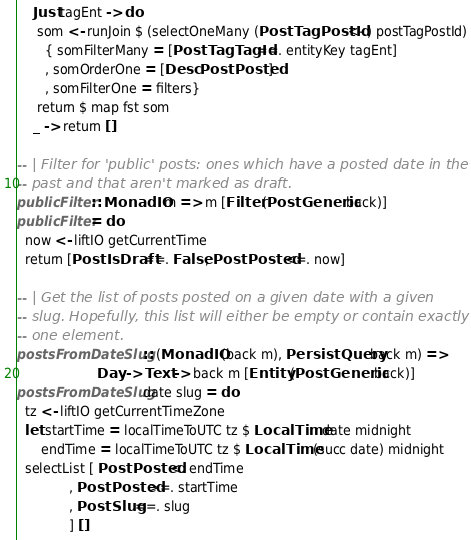<code> <loc_0><loc_0><loc_500><loc_500><_Haskell_>    Just tagEnt -> do
     som <- runJoin $ (selectOneMany (PostTagPostId <-.) postTagPostId)
       { somFilterMany = [PostTagTagId ==. entityKey tagEnt]
       , somOrderOne = [Desc PostPosted]
       , somFilterOne = filters}
     return $ map fst som
    _ -> return []

-- | Filter for 'public' posts: ones which have a posted date in the
-- past and that aren't marked as draft.
publicFilter :: MonadIO m => m [Filter (PostGeneric back)]
publicFilter = do
  now <- liftIO getCurrentTime
  return [PostIsDraft ==. False, PostPosted <=. now]

-- | Get the list of posts posted on a given date with a given
-- slug. Hopefully, this list will either be empty or contain exactly
-- one element.
postsFromDateSlug :: (MonadIO (back m), PersistQuery back m) =>
                    Day -> Text -> back m [Entity (PostGeneric back)]
postsFromDateSlug date slug = do
  tz <- liftIO getCurrentTimeZone
  let startTime = localTimeToUTC tz $ LocalTime date midnight
      endTime = localTimeToUTC tz $ LocalTime (succ date) midnight
  selectList [ PostPosted <. endTime
             , PostPosted >=. startTime
             , PostSlug ==. slug
             ] []</code> 